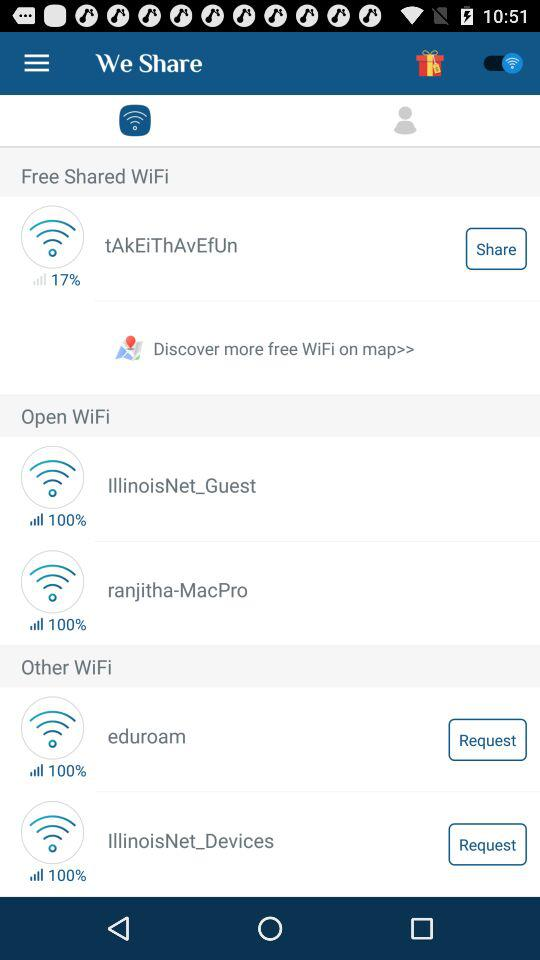How many wifi networks are there in the Other WiFi section?
Answer the question using a single word or phrase. 2 